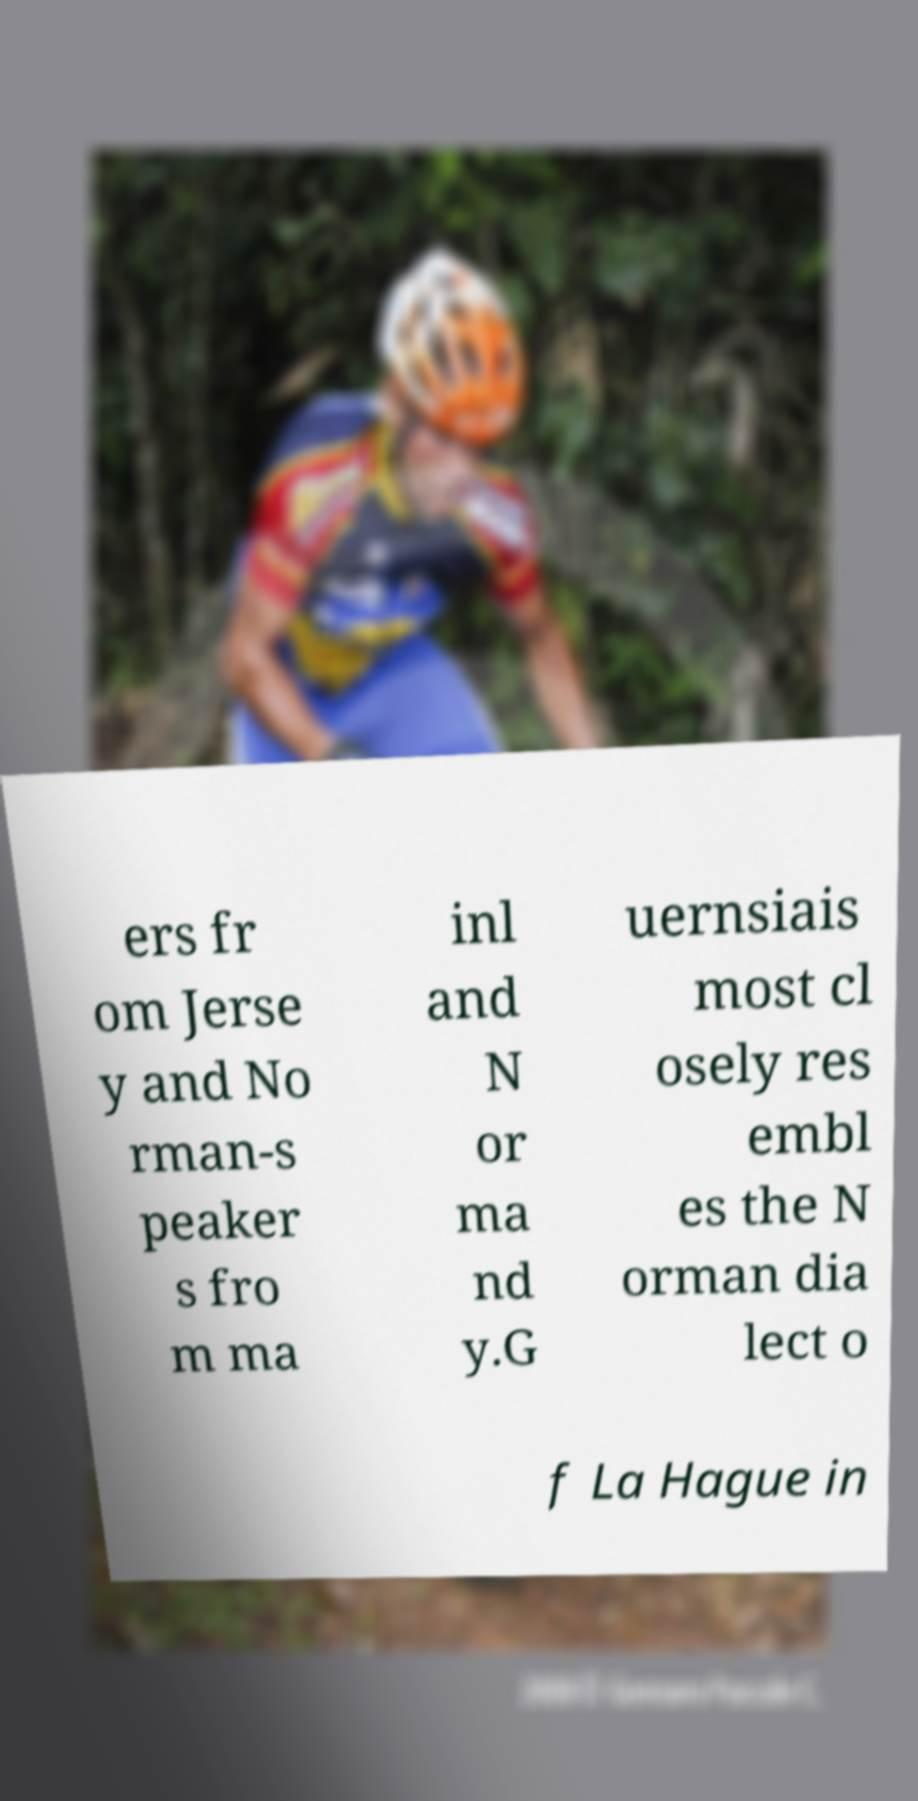I need the written content from this picture converted into text. Can you do that? ers fr om Jerse y and No rman-s peaker s fro m ma inl and N or ma nd y.G uernsiais most cl osely res embl es the N orman dia lect o f La Hague in 